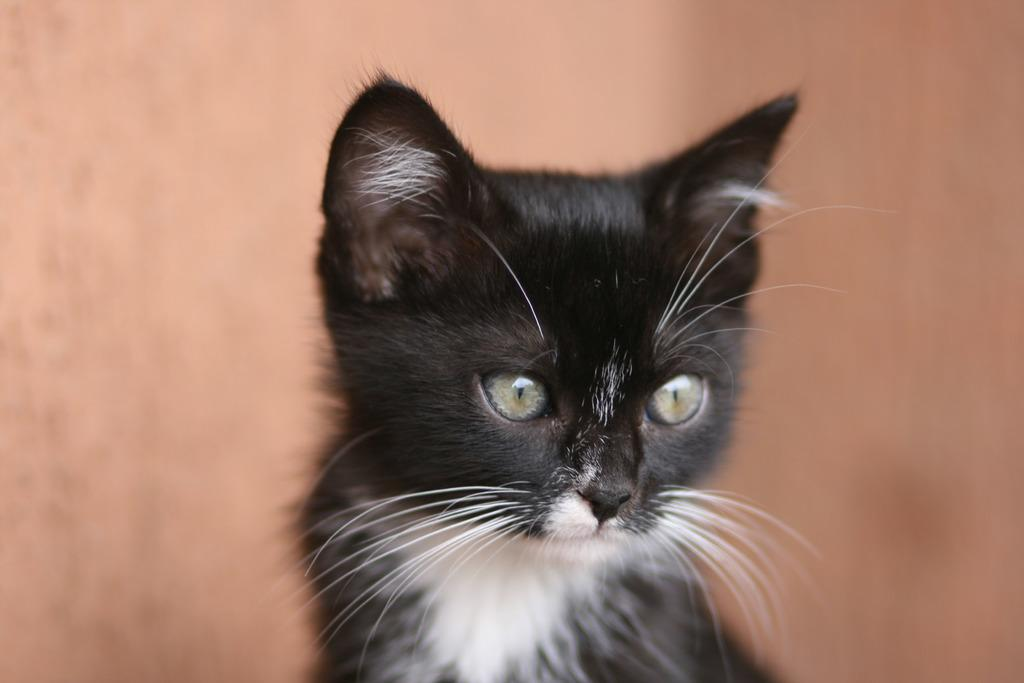What is the main subject of the image? The main subject of the image is a car. What colors are used to paint the car? The car is black and white colored. How many eggs are visible on the car in the image? There are no eggs present in the image; it features a black and white car. What type of smoke is coming out of the car's exhaust in the image? There is no smoke coming out of the car's exhaust in the image, as it only shows the car's exterior. 